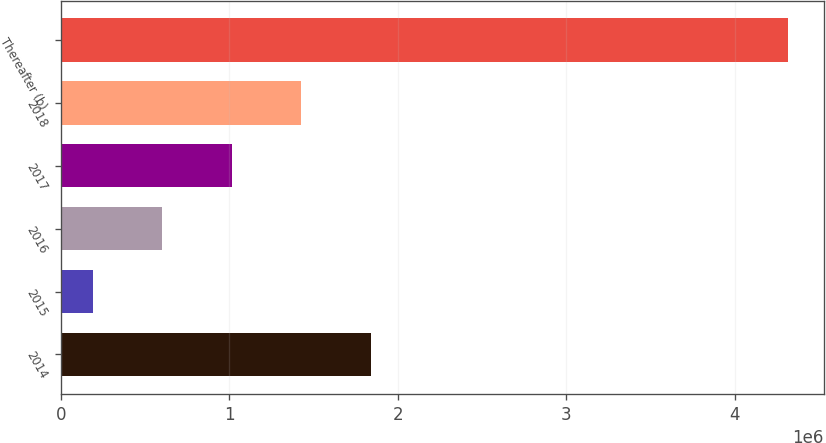<chart> <loc_0><loc_0><loc_500><loc_500><bar_chart><fcel>2014<fcel>2015<fcel>2016<fcel>2017<fcel>2018<fcel>Thereafter (b)<nl><fcel>1.83907e+06<fcel>188980<fcel>601504<fcel>1.01403e+06<fcel>1.42655e+06<fcel>4.31422e+06<nl></chart> 